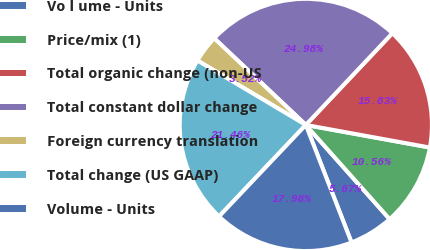Convert chart. <chart><loc_0><loc_0><loc_500><loc_500><pie_chart><fcel>Vo l ume - Units<fcel>Price/mix (1)<fcel>Total organic change (non-US<fcel>Total constant dollar change<fcel>Foreign currency translation<fcel>Total change (US GAAP)<fcel>Volume - Units<nl><fcel>5.67%<fcel>10.56%<fcel>15.83%<fcel>24.98%<fcel>3.52%<fcel>21.46%<fcel>17.98%<nl></chart> 